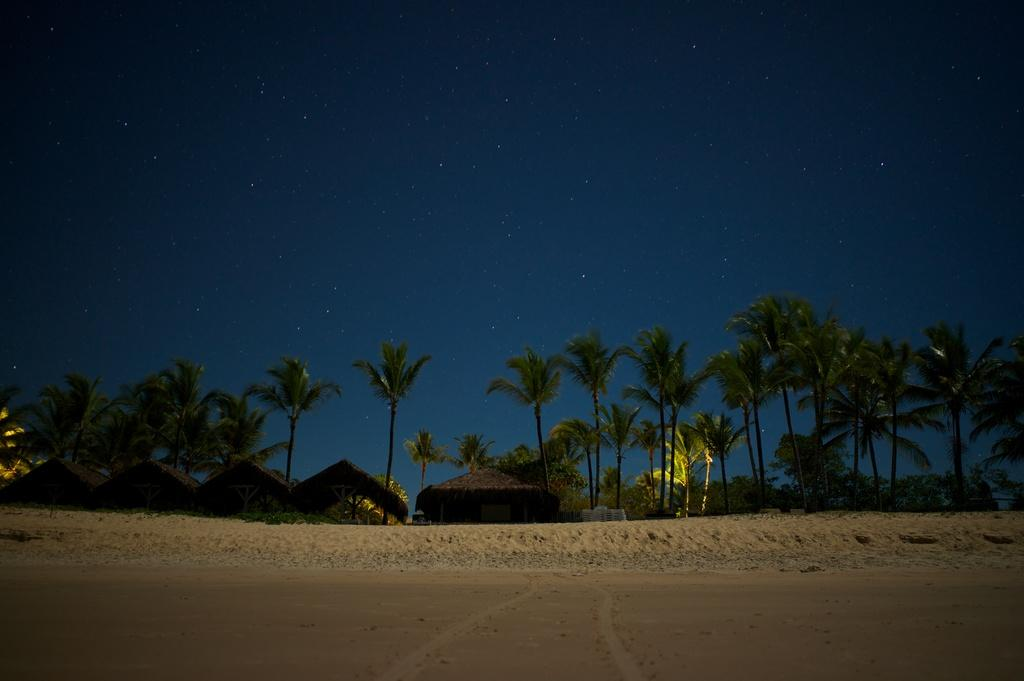What type of vegetation can be seen in the image? There are trees in the image. What type of structures are present in the image? There are huts in the image. How many bees can be seen flying around the huts in the image? There are no bees visible in the image; it only features trees and huts. What direction is the back of the huts facing in the image? The image does not provide information about the direction the huts are facing, as it only shows the front of the huts. 